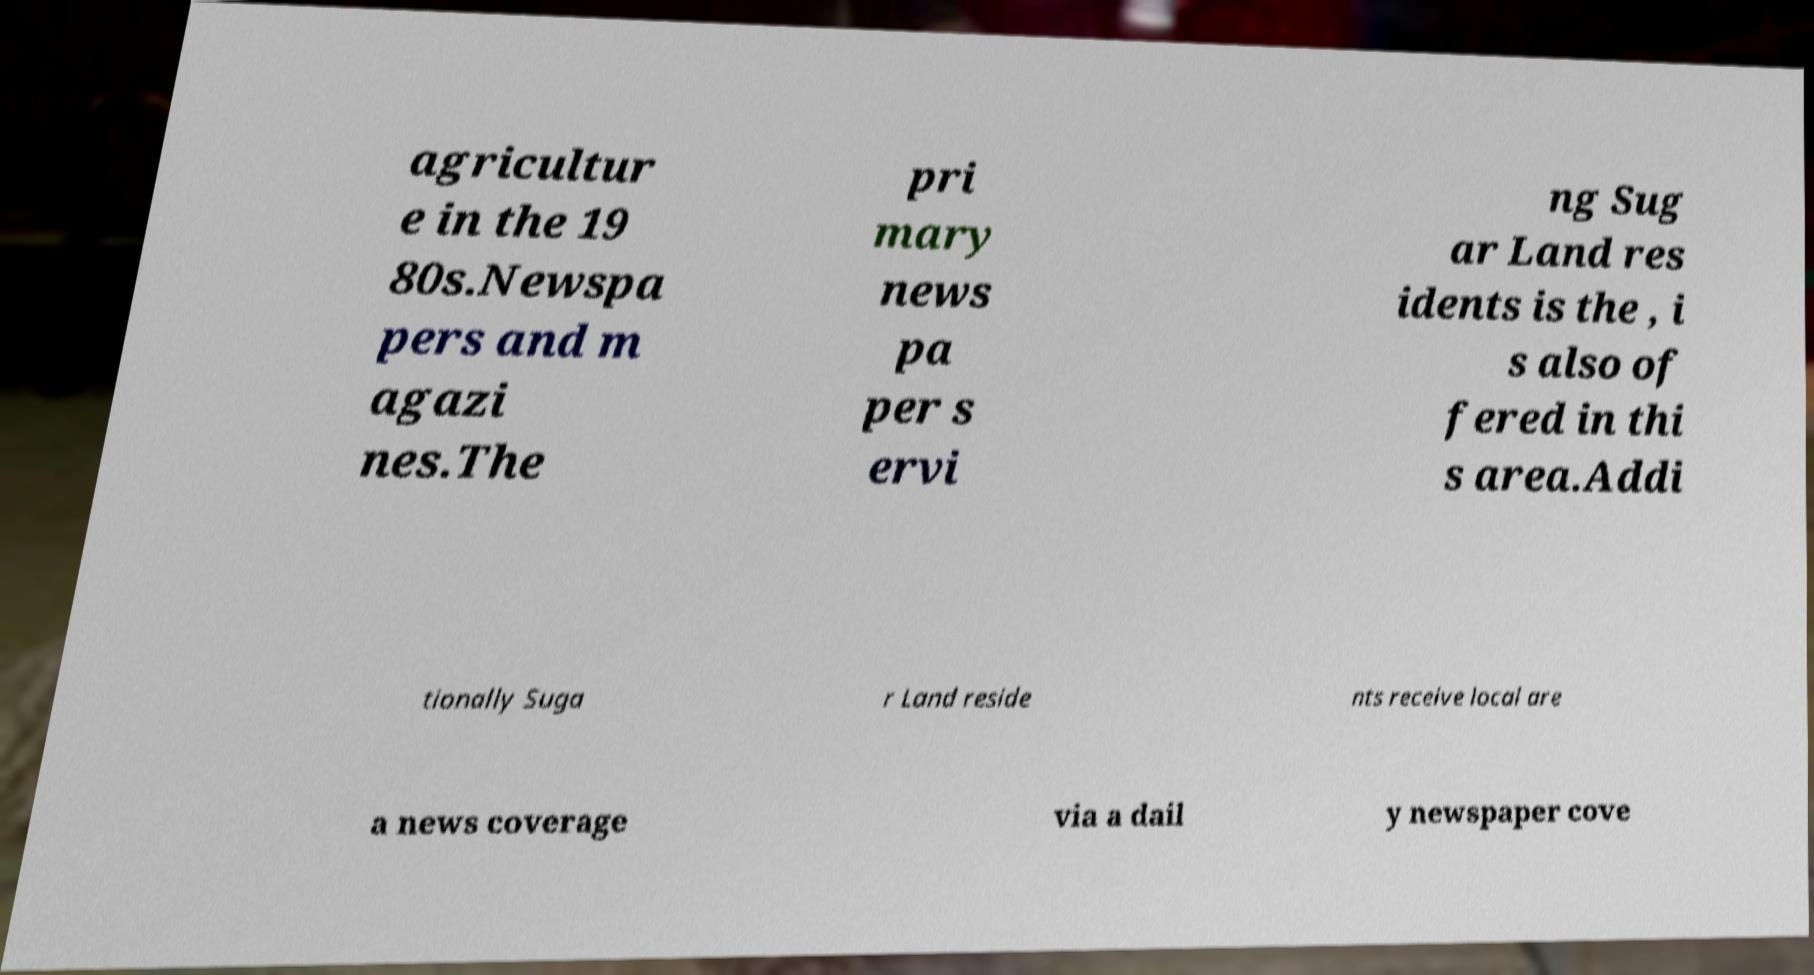What messages or text are displayed in this image? I need them in a readable, typed format. agricultur e in the 19 80s.Newspa pers and m agazi nes.The pri mary news pa per s ervi ng Sug ar Land res idents is the , i s also of fered in thi s area.Addi tionally Suga r Land reside nts receive local are a news coverage via a dail y newspaper cove 